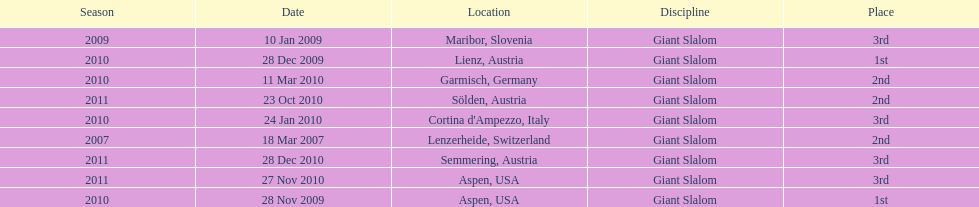Write the full table. {'header': ['Season', 'Date', 'Location', 'Discipline', 'Place'], 'rows': [['2009', '10 Jan 2009', 'Maribor, Slovenia', 'Giant Slalom', '3rd'], ['2010', '28 Dec 2009', 'Lienz, Austria', 'Giant Slalom', '1st'], ['2010', '11 Mar 2010', 'Garmisch, Germany', 'Giant Slalom', '2nd'], ['2011', '23 Oct 2010', 'Sölden, Austria', 'Giant Slalom', '2nd'], ['2010', '24 Jan 2010', "Cortina d'Ampezzo, Italy", 'Giant Slalom', '3rd'], ['2007', '18 Mar 2007', 'Lenzerheide, Switzerland', 'Giant Slalom', '2nd'], ['2011', '28 Dec 2010', 'Semmering, Austria', 'Giant Slalom', '3rd'], ['2011', '27 Nov 2010', 'Aspen, USA', 'Giant Slalom', '3rd'], ['2010', '28 Nov 2009', 'Aspen, USA', 'Giant Slalom', '1st']]} What is the total number of her 2nd place finishes on the list? 3. 